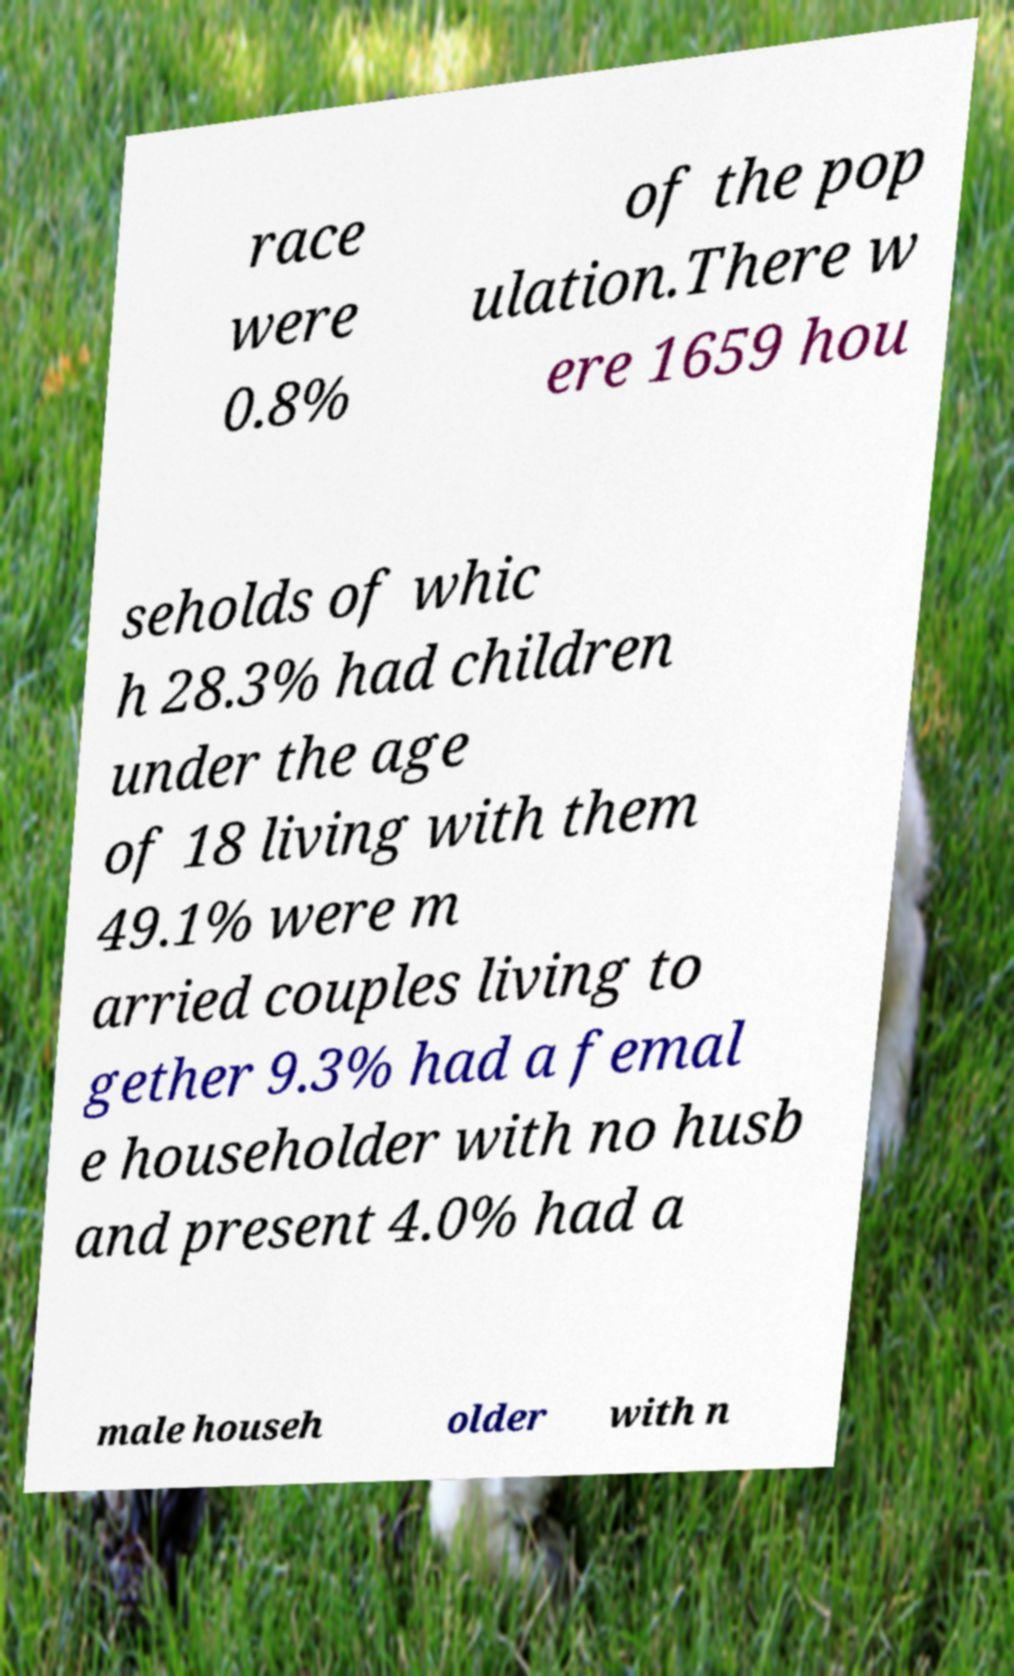There's text embedded in this image that I need extracted. Can you transcribe it verbatim? race were 0.8% of the pop ulation.There w ere 1659 hou seholds of whic h 28.3% had children under the age of 18 living with them 49.1% were m arried couples living to gether 9.3% had a femal e householder with no husb and present 4.0% had a male househ older with n 